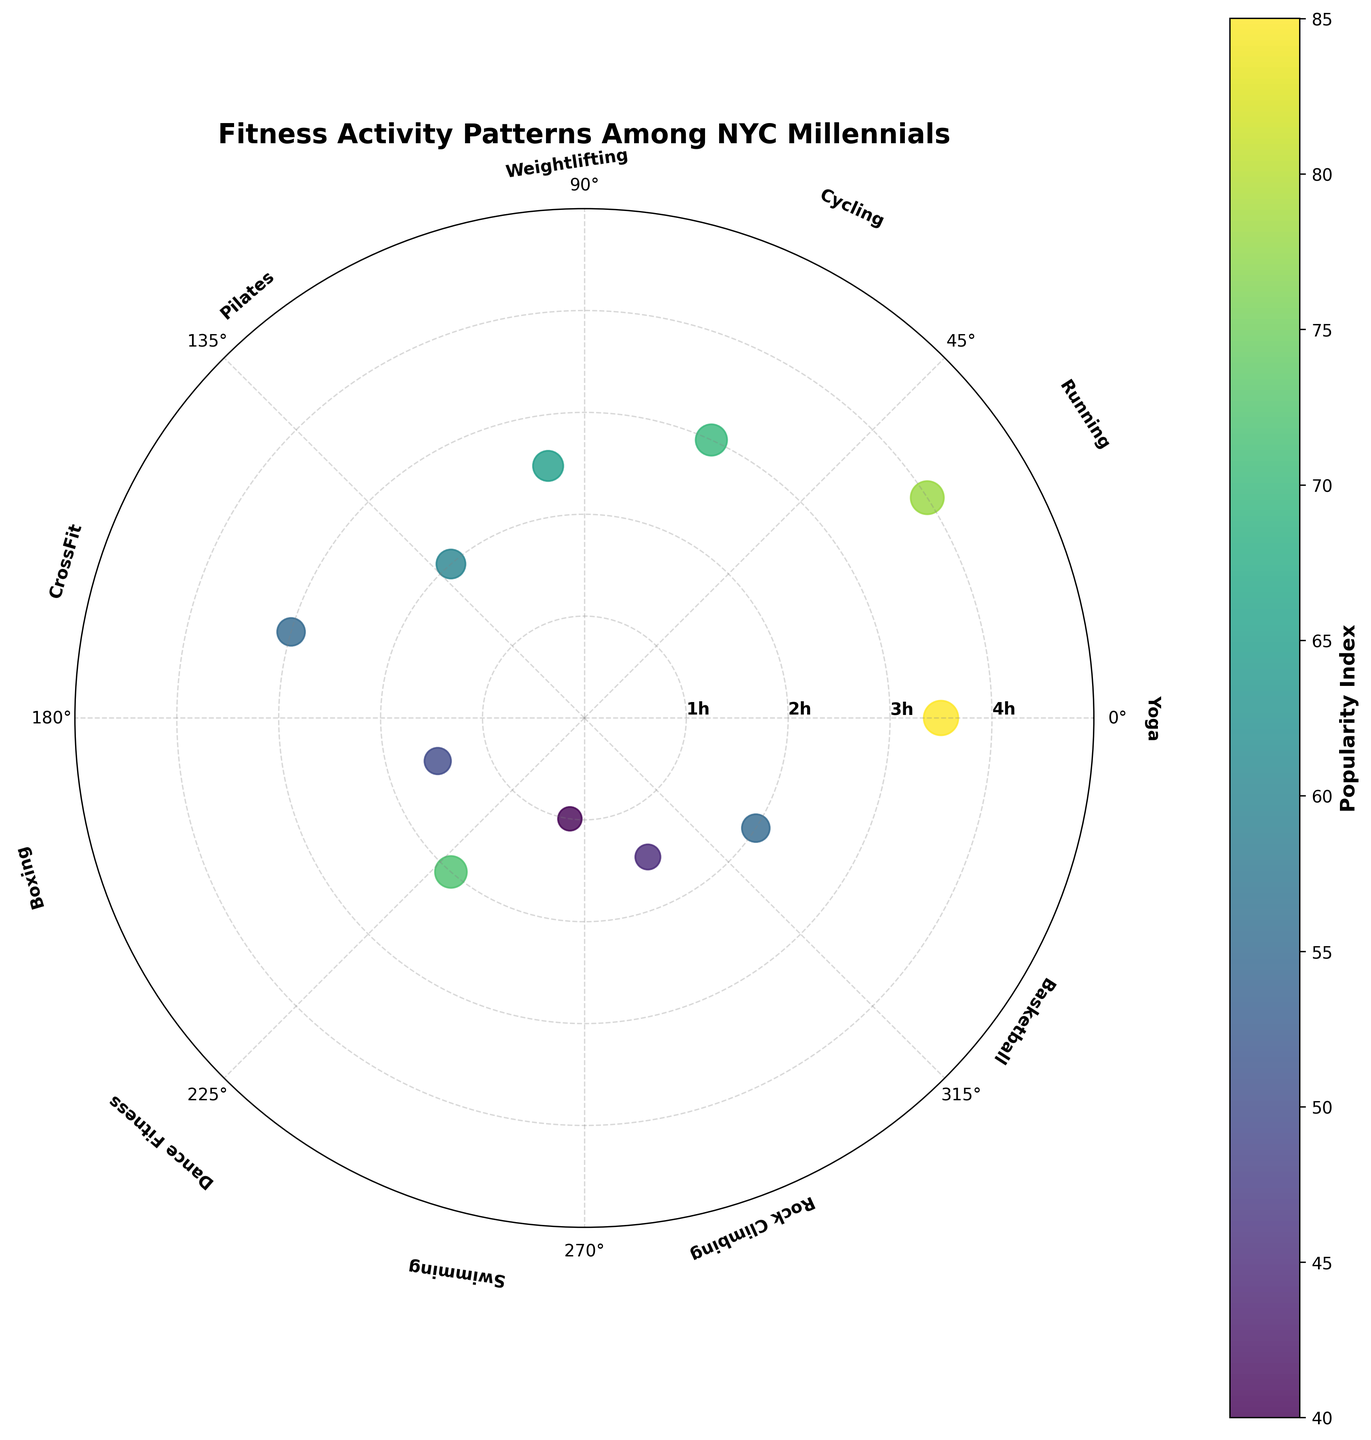What is the exercise type with the highest "Hours per Week"? By observing the outermost points on the radial axis, the longest radial line corresponds to "Running" at 4.0 hours per week.
Answer: Running Which exercise type has the highest "Popularity Index"? The size and color of the scatter points indicate the "Popularity Index" with larger and more vibrant points representing higher popularity. "Yoga" has the largest and darkest point, so it has the highest popularity index.
Answer: Yoga What is the trend between "Hours per Week" and "Popularity Index"? By observing the scatter points, there is no clear linear trend between "Hours per Week" and "Popularity Index"; some activities with lower hours have high popularity indexes and vice versa.
Answer: No clear trend How many exercise types have "Popularity Index" below 60? By counting the points with sizes (and corresponding color) less than those indicative of 60, we find three exercises in this range (Swimming, Rock Climbing, and Boxing).
Answer: Three Which two exercise types are closest in terms of "Hours per Week"? Observing the radial positions, "CrossFit" and "Cycling" are closest, both at 3.0 hours per week.
Answer: CrossFit and Cycling Between "Yoga" and "Cycling," which has a higher "Popularity Index"? Observing the plot, "Yoga" has a higher "Popularity Index" than "Cycling" as indicated by the size and color of the scatter points.
Answer: Yoga What is the average "Hours per Week" for the listed exercises? Calculate the sum of all "Hours per Week" values: \(3.5 + 4.0 + 3.0 + 2.5 + 2.0 + 3.0 + 1.5 + 2.0 + 1.0 + 1.5 + 2.0 = 26\). Divide by the number of exercises (11): \(26/11 \approx 2.36\).
Answer: 2.36 What is the range of "Popularity Index" among all the exercises? The highest "Popularity Index" is 85 (Yoga), and the lowest is 40 (Swimming). The range is calculated as \(85 - 40 = 45\).
Answer: 45 Which exercise is the most popular among those with less than 2 hours per week? For exercises less than 2 hours per week ("Boxing", "Swimming", "Rock Climbing"), "Boxing" has the highest "Popularity Index" at 50.
Answer: Boxing Between "Dance Fitness" and "Pilates", which is more popular, and by how much? "Dance Fitness" has a "Popularity Index" of 72, and "Pilates" has 60. The difference is \(72 - 60 = 12\). So, "Dance Fitness" is more popular by 12.
Answer: Dance Fitness by 12 